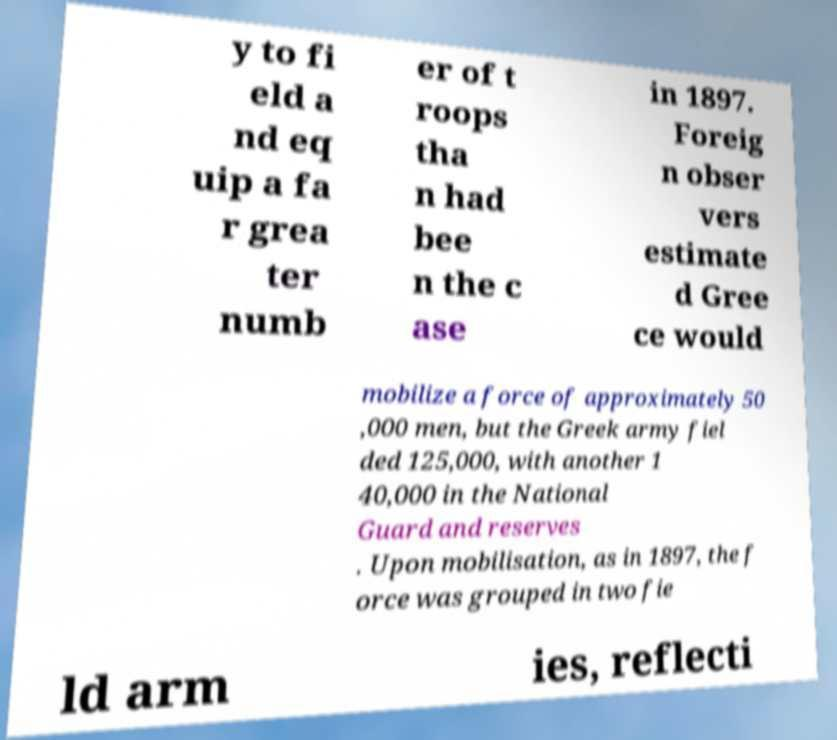Please identify and transcribe the text found in this image. y to fi eld a nd eq uip a fa r grea ter numb er of t roops tha n had bee n the c ase in 1897. Foreig n obser vers estimate d Gree ce would mobilize a force of approximately 50 ,000 men, but the Greek army fiel ded 125,000, with another 1 40,000 in the National Guard and reserves . Upon mobilisation, as in 1897, the f orce was grouped in two fie ld arm ies, reflecti 